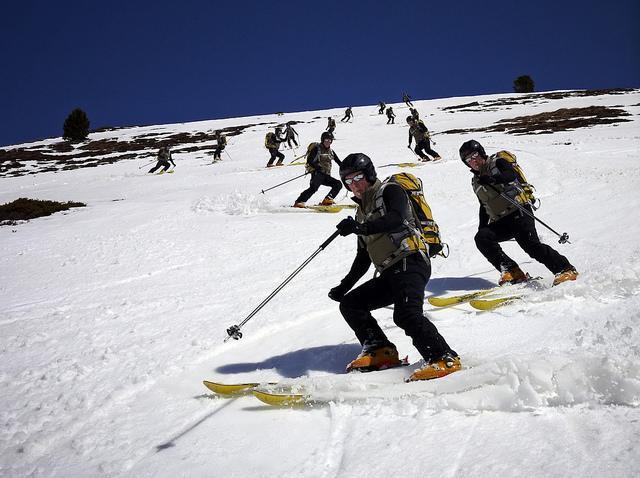How many bushes do you see?
Give a very brief answer. 2. How many people are there?
Give a very brief answer. 3. How many boats are there?
Give a very brief answer. 0. 